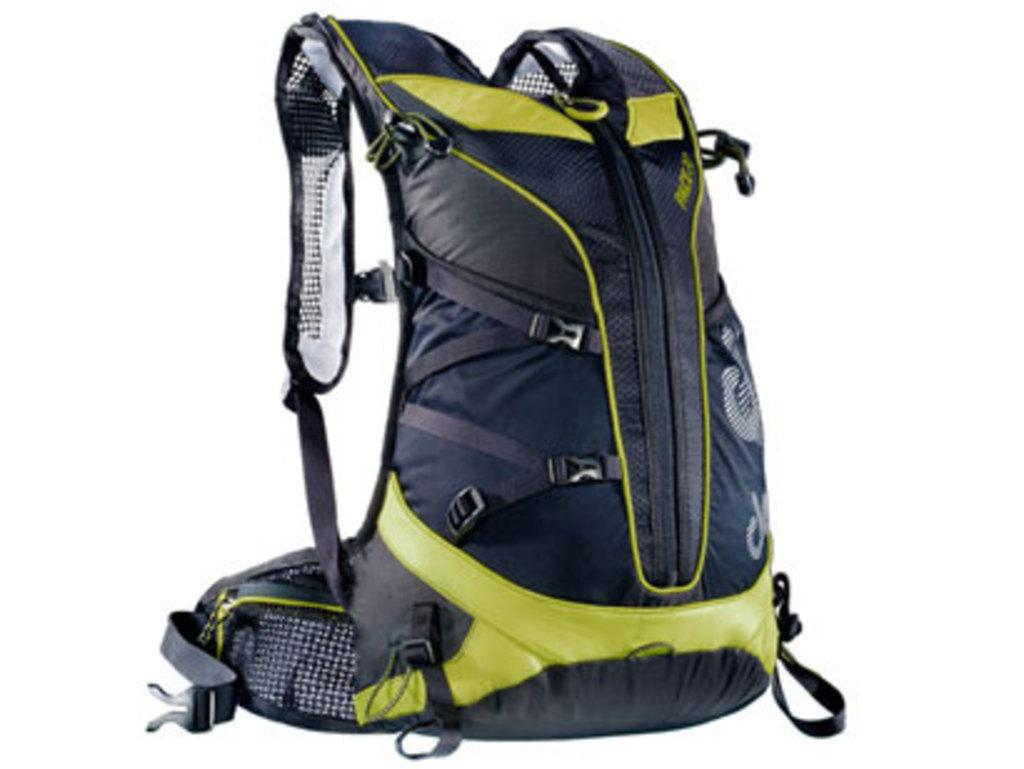What is the main object in the image? There is a safety bag in the image. How many basketball is being played in the aftermath of the branch falling in the image? There is no basketball, aftermath, or branch present in the image; it only features a safety bag. 